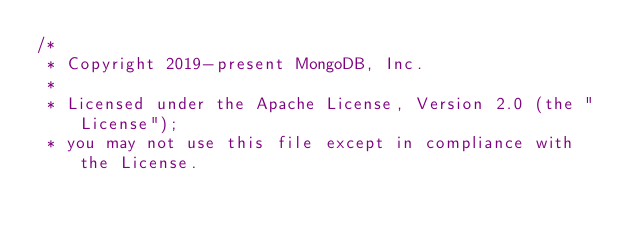<code> <loc_0><loc_0><loc_500><loc_500><_C_>/*
 * Copyright 2019-present MongoDB, Inc.
 *
 * Licensed under the Apache License, Version 2.0 (the "License");
 * you may not use this file except in compliance with the License.</code> 